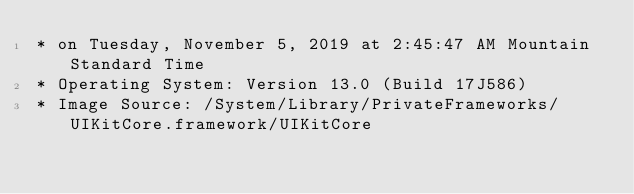Convert code to text. <code><loc_0><loc_0><loc_500><loc_500><_C_>* on Tuesday, November 5, 2019 at 2:45:47 AM Mountain Standard Time
* Operating System: Version 13.0 (Build 17J586)
* Image Source: /System/Library/PrivateFrameworks/UIKitCore.framework/UIKitCore</code> 